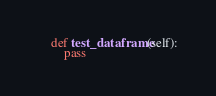<code> <loc_0><loc_0><loc_500><loc_500><_Python_>
    def test_dataframe(self):
        pass</code> 